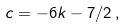Convert formula to latex. <formula><loc_0><loc_0><loc_500><loc_500>c = - 6 k - 7 / 2 \, ,</formula> 